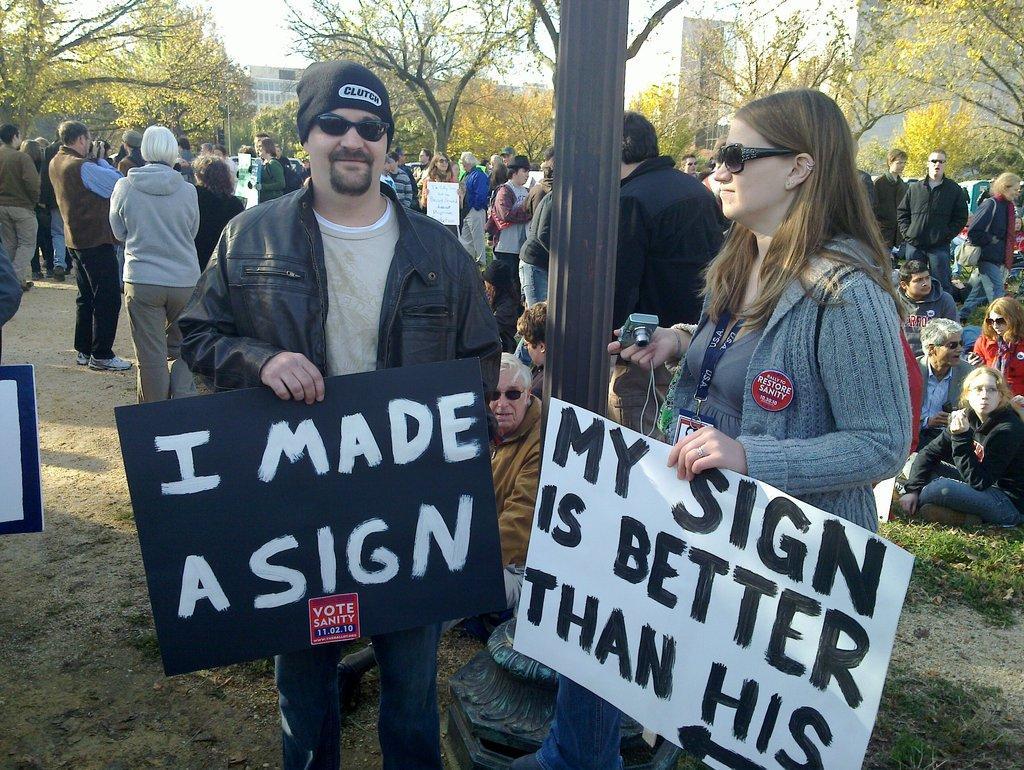In one or two sentences, can you explain what this image depicts? In this image, I can see the man and woman standing and holding the boards. This looks like a pole. I can see groups of people standing and few people sitting. This is the grass. These are the trees with branches and leaves. In the background, I can see the buildings. 